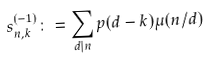Convert formula to latex. <formula><loc_0><loc_0><loc_500><loc_500>s _ { n , k } ^ { ( - 1 ) } & \colon = \sum _ { d | n } p ( d - k ) \mu ( n / d )</formula> 